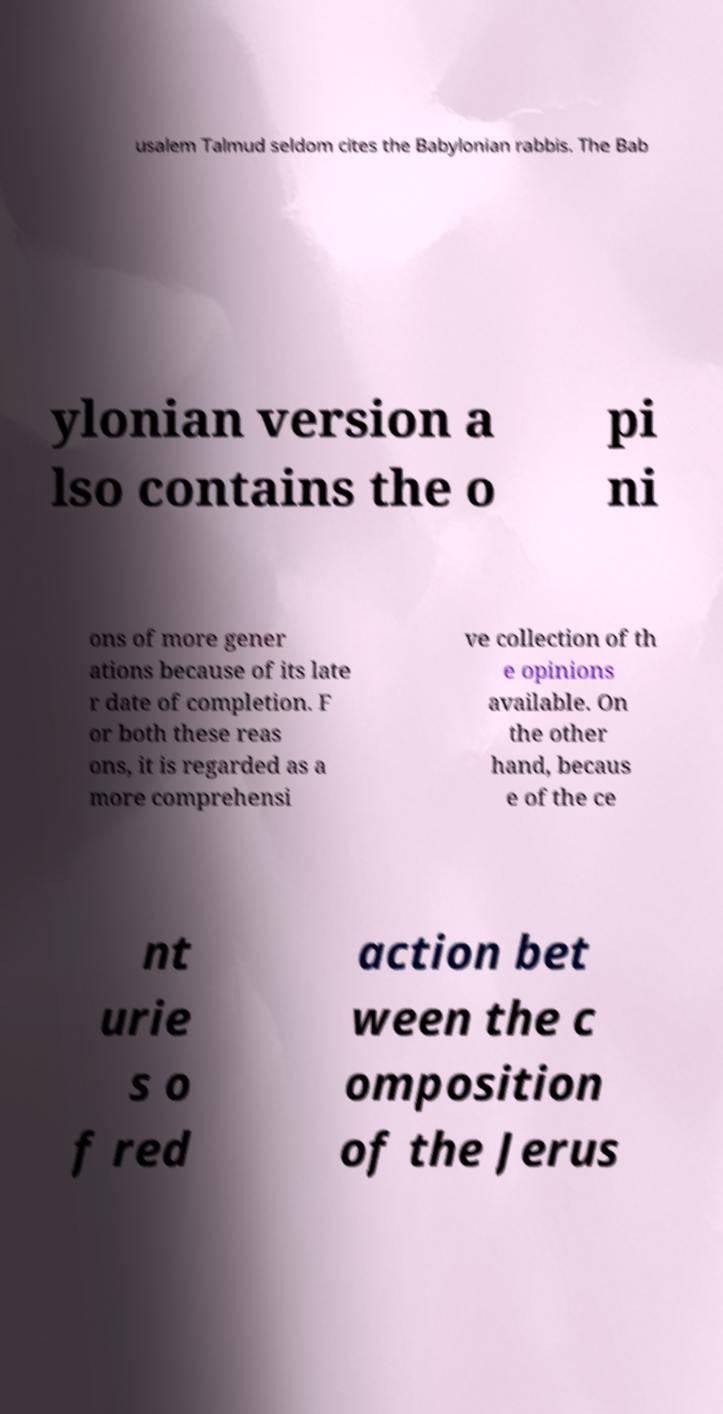Can you accurately transcribe the text from the provided image for me? usalem Talmud seldom cites the Babylonian rabbis. The Bab ylonian version a lso contains the o pi ni ons of more gener ations because of its late r date of completion. F or both these reas ons, it is regarded as a more comprehensi ve collection of th e opinions available. On the other hand, becaus e of the ce nt urie s o f red action bet ween the c omposition of the Jerus 